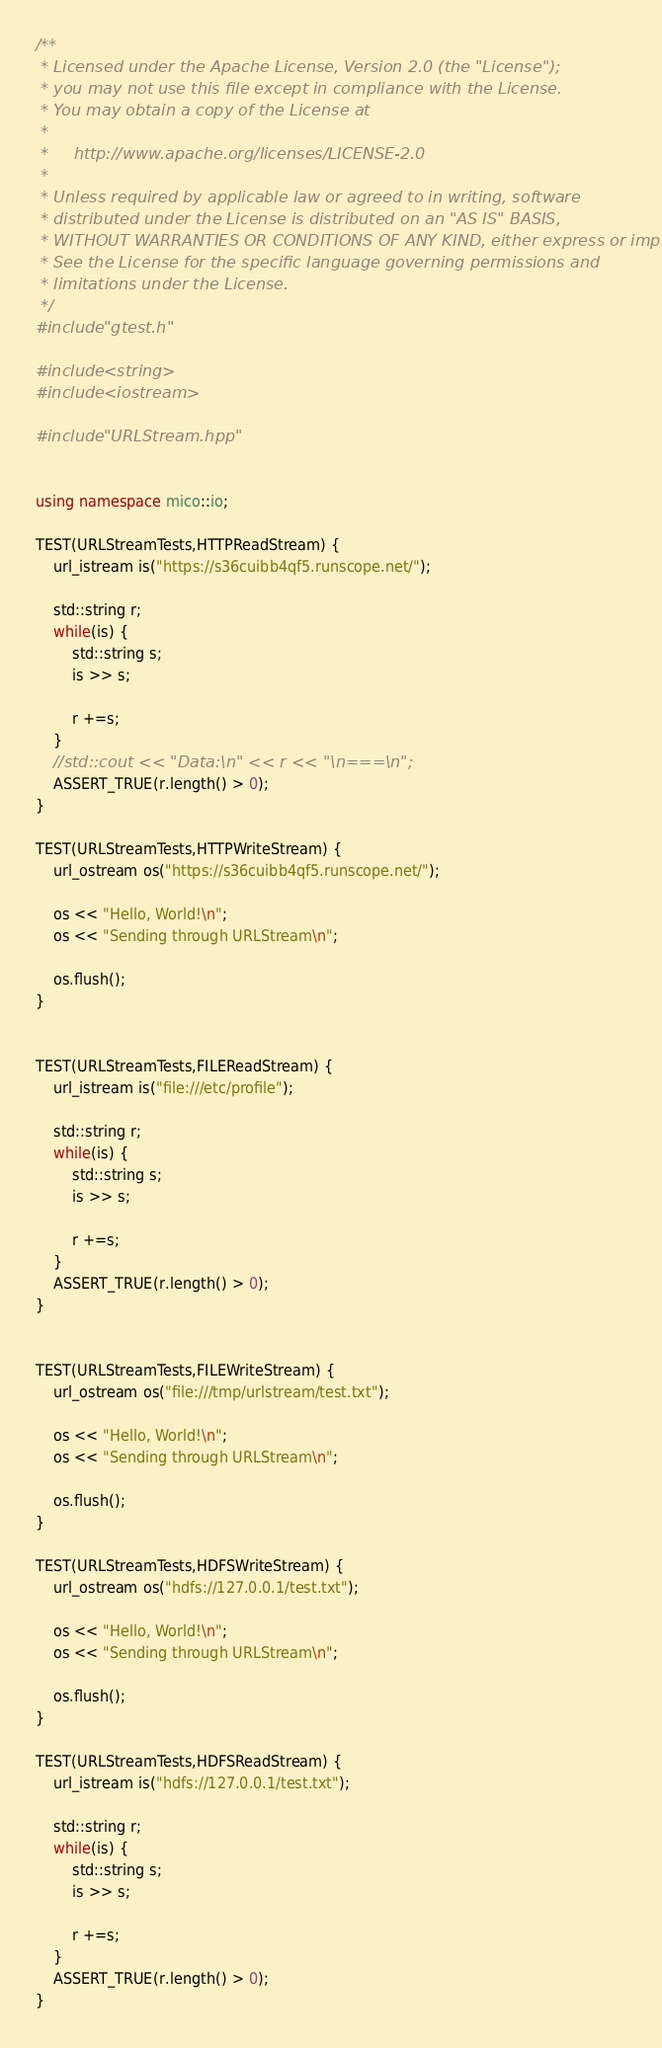<code> <loc_0><loc_0><loc_500><loc_500><_C++_>/**
 * Licensed under the Apache License, Version 2.0 (the "License");
 * you may not use this file except in compliance with the License.
 * You may obtain a copy of the License at
 *
 *     http://www.apache.org/licenses/LICENSE-2.0
 *
 * Unless required by applicable law or agreed to in writing, software
 * distributed under the License is distributed on an "AS IS" BASIS,
 * WITHOUT WARRANTIES OR CONDITIONS OF ANY KIND, either express or implied.
 * See the License for the specific language governing permissions and
 * limitations under the License.
 */
#include "gtest.h"

#include <string>
#include <iostream>

#include "URLStream.hpp"


using namespace mico::io;

TEST(URLStreamTests,HTTPReadStream) {
	url_istream is("https://s36cuibb4qf5.runscope.net/");
	
	std::string r;
	while(is) {
		std::string s;
		is >> s;
		
		r +=s;
	}
	//std::cout << "Data:\n" << r << "\n===\n";
	ASSERT_TRUE(r.length() > 0);
}

TEST(URLStreamTests,HTTPWriteStream) {
	url_ostream os("https://s36cuibb4qf5.runscope.net/");
	
	os << "Hello, World!\n";
	os << "Sending through URLStream\n";
	
	os.flush();
}


TEST(URLStreamTests,FILEReadStream) {
	url_istream is("file:///etc/profile");
	
	std::string r;
	while(is) {
		std::string s;
		is >> s;
		
		r +=s;
	}
	ASSERT_TRUE(r.length() > 0);
}


TEST(URLStreamTests,FILEWriteStream) {
	url_ostream os("file:///tmp/urlstream/test.txt");
	
	os << "Hello, World!\n";
	os << "Sending through URLStream\n";
	
	os.flush();
}

TEST(URLStreamTests,HDFSWriteStream) {
	url_ostream os("hdfs://127.0.0.1/test.txt");

	os << "Hello, World!\n";
	os << "Sending through URLStream\n";

	os.flush();
}

TEST(URLStreamTests,HDFSReadStream) {
	url_istream is("hdfs://127.0.0.1/test.txt");

	std::string r;
	while(is) {
		std::string s;
		is >> s;

		r +=s;
	}
	ASSERT_TRUE(r.length() > 0);
}
</code> 